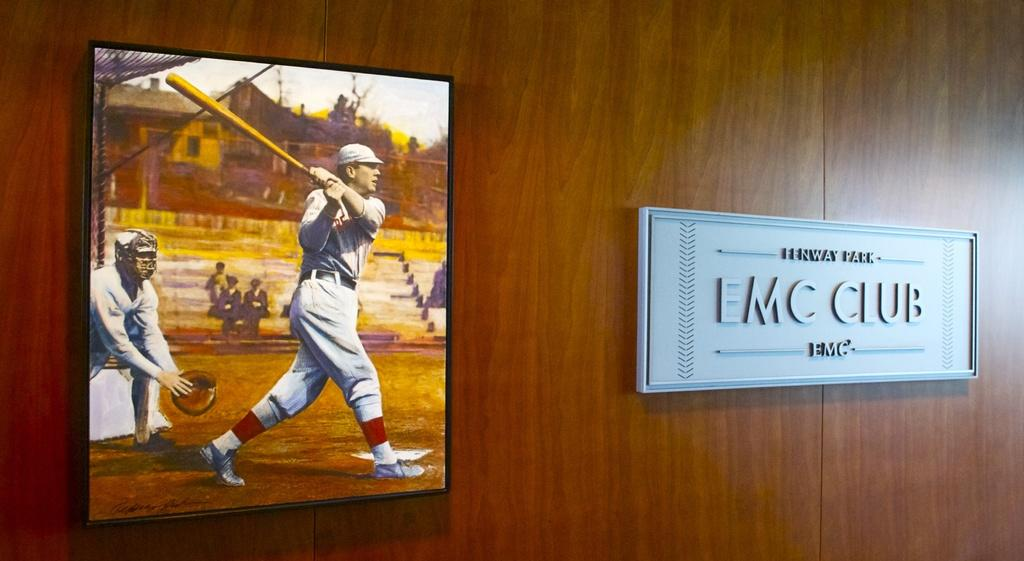Provide a one-sentence caption for the provided image. a painting of baseball players near a plaque for the emc club. 